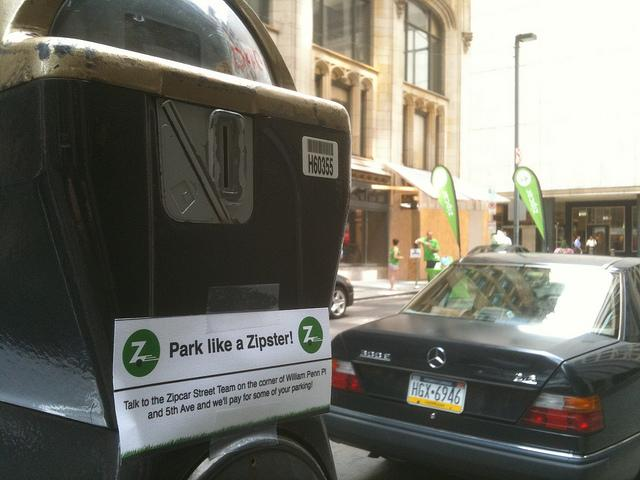What make of car can be seen next to the parking meter?

Choices:
A) mercedes
B) acura
C) audi
D) bmw mercedes 